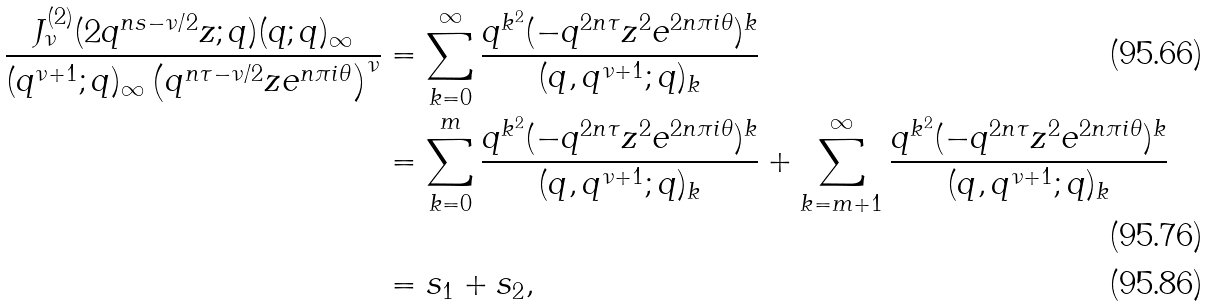Convert formula to latex. <formula><loc_0><loc_0><loc_500><loc_500>\frac { J _ { \nu } ^ { ( 2 ) } ( 2 q ^ { n s - \nu / 2 } z ; q ) ( q ; q ) _ { \infty } } { ( q ^ { \nu + 1 } ; q ) _ { \infty } \left ( q ^ { n \tau - \nu / 2 } z e ^ { n \pi i \theta } \right ) ^ { \nu } } & = \sum _ { k = 0 } ^ { \infty } \frac { q ^ { k ^ { 2 } } ( - q ^ { 2 n \tau } z ^ { 2 } e ^ { 2 n \pi i \theta } ) ^ { k } } { ( q , q ^ { \nu + 1 } ; q ) _ { k } } \\ & = \sum _ { k = 0 } ^ { m } \frac { q ^ { k ^ { 2 } } ( - q ^ { 2 n \tau } z ^ { 2 } e ^ { 2 n \pi i \theta } ) ^ { k } } { ( q , q ^ { \nu + 1 } ; q ) _ { k } } + \sum _ { k = m + 1 } ^ { \infty } \frac { q ^ { k ^ { 2 } } ( - q ^ { 2 n \tau } z ^ { 2 } e ^ { 2 n \pi i \theta } ) ^ { k } } { ( q , q ^ { \nu + 1 } ; q ) _ { k } } \\ & = s _ { 1 } + s _ { 2 } ,</formula> 